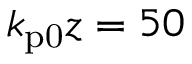<formula> <loc_0><loc_0><loc_500><loc_500>k _ { p 0 } z = 5 0</formula> 